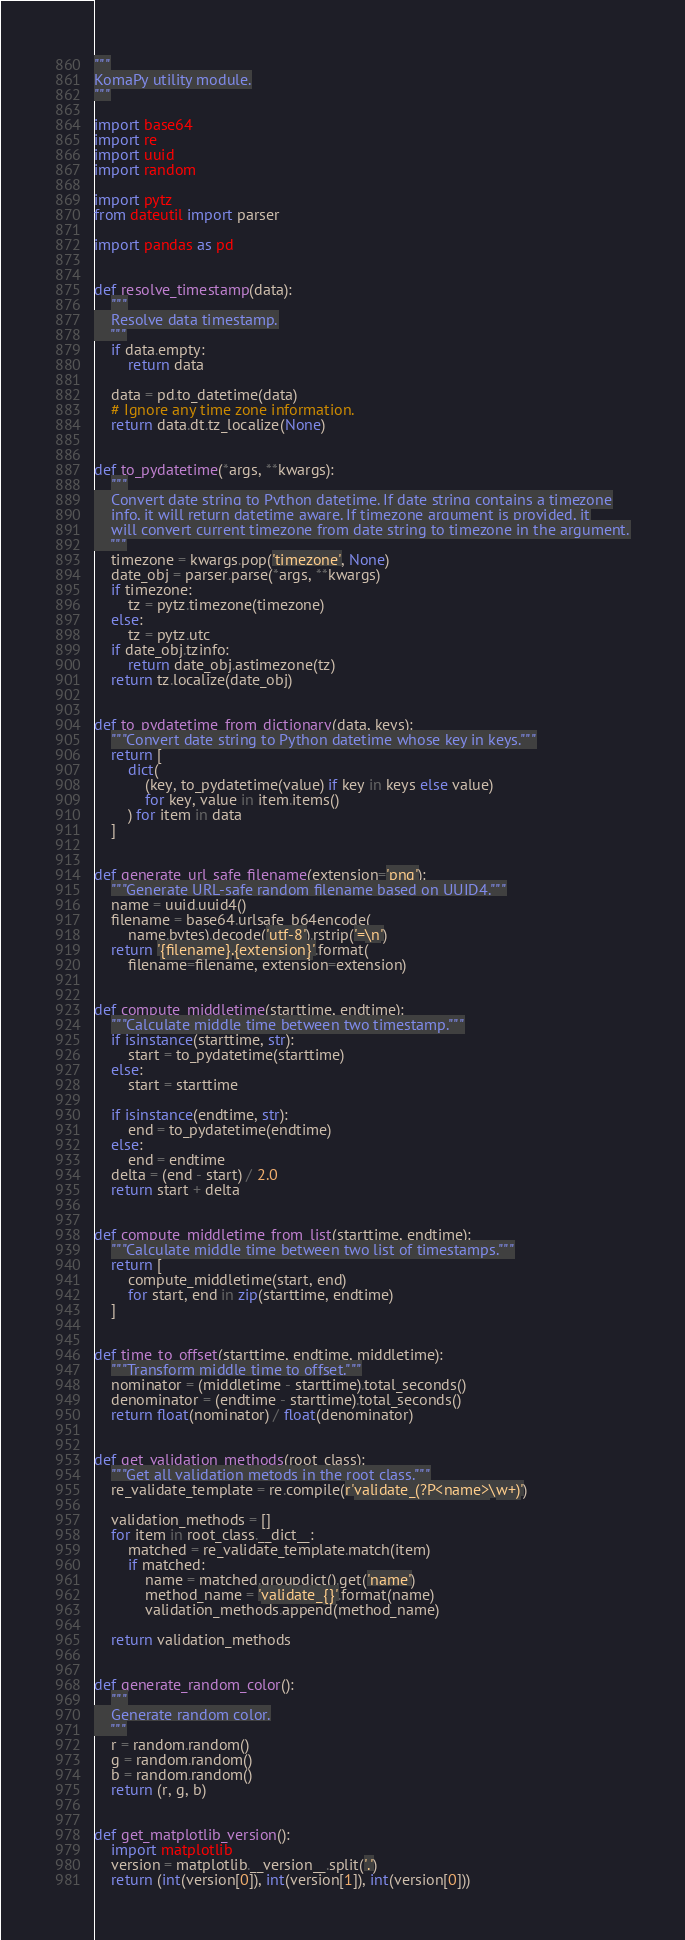<code> <loc_0><loc_0><loc_500><loc_500><_Python_>"""
KomaPy utility module.
"""

import base64
import re
import uuid
import random

import pytz
from dateutil import parser

import pandas as pd


def resolve_timestamp(data):
    """
    Resolve data timestamp.
    """
    if data.empty:
        return data

    data = pd.to_datetime(data)
    # Ignore any time zone information.
    return data.dt.tz_localize(None)


def to_pydatetime(*args, **kwargs):
    """
    Convert date string to Python datetime. If date string contains a timezone
    info, it will return datetime aware. If timezone argument is provided, it
    will convert current timezone from date string to timezone in the argument.
    """
    timezone = kwargs.pop('timezone', None)
    date_obj = parser.parse(*args, **kwargs)
    if timezone:
        tz = pytz.timezone(timezone)
    else:
        tz = pytz.utc
    if date_obj.tzinfo:
        return date_obj.astimezone(tz)
    return tz.localize(date_obj)


def to_pydatetime_from_dictionary(data, keys):
    """Convert date string to Python datetime whose key in keys."""
    return [
        dict(
            (key, to_pydatetime(value) if key in keys else value)
            for key, value in item.items()
        ) for item in data
    ]


def generate_url_safe_filename(extension='png'):
    """Generate URL-safe random filename based on UUID4."""
    name = uuid.uuid4()
    filename = base64.urlsafe_b64encode(
        name.bytes).decode('utf-8').rstrip('=\n')
    return '{filename}.{extension}'.format(
        filename=filename, extension=extension)


def compute_middletime(starttime, endtime):
    """Calculate middle time between two timestamp."""
    if isinstance(starttime, str):
        start = to_pydatetime(starttime)
    else:
        start = starttime

    if isinstance(endtime, str):
        end = to_pydatetime(endtime)
    else:
        end = endtime
    delta = (end - start) / 2.0
    return start + delta


def compute_middletime_from_list(starttime, endtime):
    """Calculate middle time between two list of timestamps."""
    return [
        compute_middletime(start, end)
        for start, end in zip(starttime, endtime)
    ]


def time_to_offset(starttime, endtime, middletime):
    """Transform middle time to offset."""
    nominator = (middletime - starttime).total_seconds()
    denominator = (endtime - starttime).total_seconds()
    return float(nominator) / float(denominator)


def get_validation_methods(root_class):
    """Get all validation metods in the root class."""
    re_validate_template = re.compile(r'validate_(?P<name>\w+)')

    validation_methods = []
    for item in root_class.__dict__:
        matched = re_validate_template.match(item)
        if matched:
            name = matched.groupdict().get('name')
            method_name = 'validate_{}'.format(name)
            validation_methods.append(method_name)

    return validation_methods


def generate_random_color():
    """
    Generate random color.
    """
    r = random.random()
    g = random.random()
    b = random.random()
    return (r, g, b)


def get_matplotlib_version():
    import matplotlib
    version = matplotlib.__version__.split('.')
    return (int(version[0]), int(version[1]), int(version[0]))
</code> 